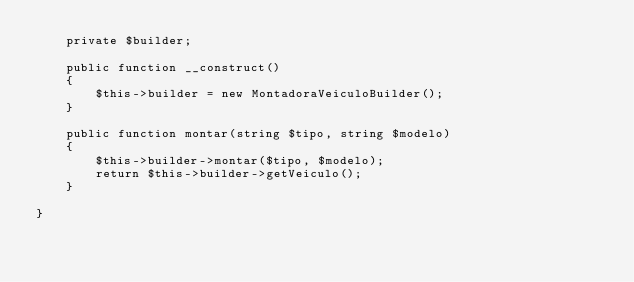<code> <loc_0><loc_0><loc_500><loc_500><_PHP_>    private $builder;

    public function __construct()
    {
        $this->builder = new MontadoraVeiculoBuilder();
    }

    public function montar(string $tipo, string $modelo)
    {
        $this->builder->montar($tipo, $modelo);
        return $this->builder->getVeiculo();
    }

}</code> 